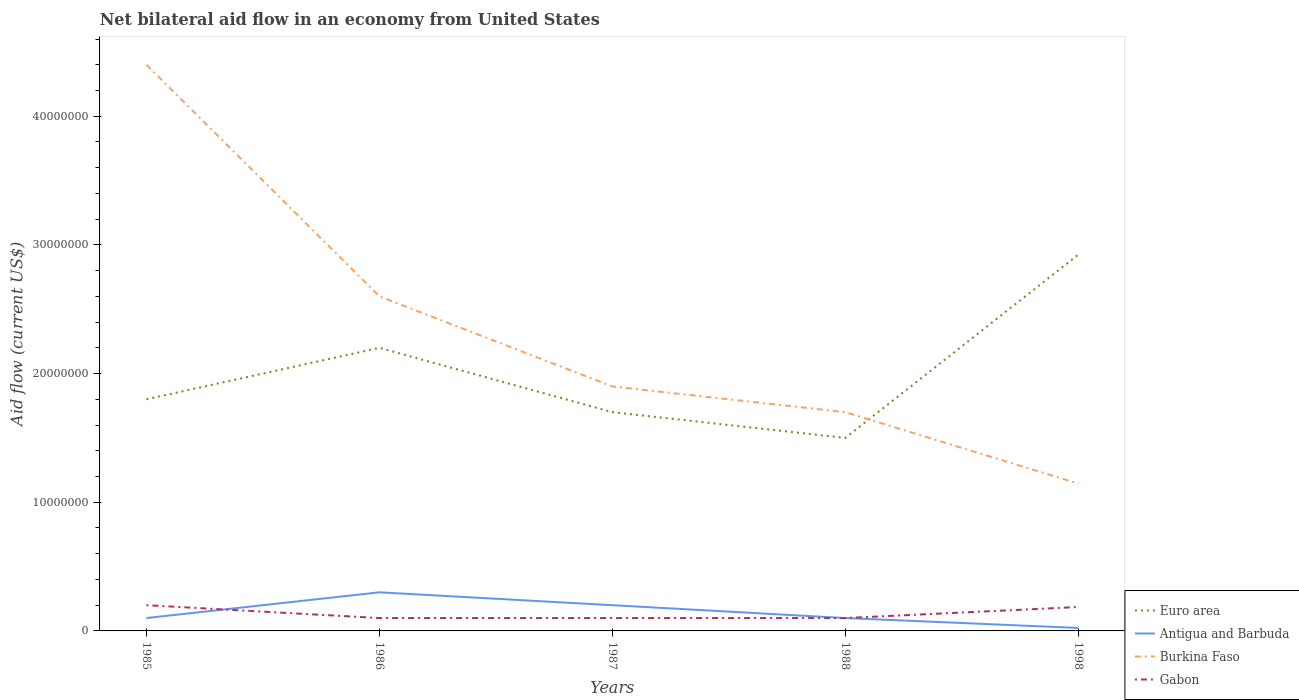Is the number of lines equal to the number of legend labels?
Your answer should be compact. Yes. Across all years, what is the maximum net bilateral aid flow in Euro area?
Offer a very short reply. 1.50e+07. What is the total net bilateral aid flow in Euro area in the graph?
Your answer should be very brief. 7.00e+06. What is the difference between the highest and the second highest net bilateral aid flow in Burkina Faso?
Keep it short and to the point. 3.26e+07. How many lines are there?
Your answer should be compact. 4. How many years are there in the graph?
Your answer should be compact. 5. What is the difference between two consecutive major ticks on the Y-axis?
Your answer should be very brief. 1.00e+07. Are the values on the major ticks of Y-axis written in scientific E-notation?
Your response must be concise. No. Does the graph contain any zero values?
Your response must be concise. No. How are the legend labels stacked?
Keep it short and to the point. Vertical. What is the title of the graph?
Your response must be concise. Net bilateral aid flow in an economy from United States. What is the label or title of the X-axis?
Your answer should be compact. Years. What is the Aid flow (current US$) in Euro area in 1985?
Offer a very short reply. 1.80e+07. What is the Aid flow (current US$) in Burkina Faso in 1985?
Your answer should be very brief. 4.40e+07. What is the Aid flow (current US$) in Gabon in 1985?
Offer a terse response. 2.00e+06. What is the Aid flow (current US$) of Euro area in 1986?
Your answer should be very brief. 2.20e+07. What is the Aid flow (current US$) of Burkina Faso in 1986?
Give a very brief answer. 2.60e+07. What is the Aid flow (current US$) in Gabon in 1986?
Your answer should be compact. 1.00e+06. What is the Aid flow (current US$) in Euro area in 1987?
Keep it short and to the point. 1.70e+07. What is the Aid flow (current US$) of Antigua and Barbuda in 1987?
Offer a very short reply. 2.00e+06. What is the Aid flow (current US$) in Burkina Faso in 1987?
Provide a succinct answer. 1.90e+07. What is the Aid flow (current US$) in Gabon in 1987?
Provide a succinct answer. 1.00e+06. What is the Aid flow (current US$) in Euro area in 1988?
Your answer should be very brief. 1.50e+07. What is the Aid flow (current US$) of Burkina Faso in 1988?
Offer a very short reply. 1.70e+07. What is the Aid flow (current US$) of Euro area in 1998?
Ensure brevity in your answer.  2.92e+07. What is the Aid flow (current US$) of Antigua and Barbuda in 1998?
Make the answer very short. 2.30e+05. What is the Aid flow (current US$) of Burkina Faso in 1998?
Provide a succinct answer. 1.14e+07. What is the Aid flow (current US$) of Gabon in 1998?
Ensure brevity in your answer.  1.86e+06. Across all years, what is the maximum Aid flow (current US$) in Euro area?
Your answer should be compact. 2.92e+07. Across all years, what is the maximum Aid flow (current US$) of Burkina Faso?
Give a very brief answer. 4.40e+07. Across all years, what is the maximum Aid flow (current US$) of Gabon?
Make the answer very short. 2.00e+06. Across all years, what is the minimum Aid flow (current US$) in Euro area?
Your answer should be compact. 1.50e+07. Across all years, what is the minimum Aid flow (current US$) of Burkina Faso?
Give a very brief answer. 1.14e+07. What is the total Aid flow (current US$) in Euro area in the graph?
Offer a very short reply. 1.01e+08. What is the total Aid flow (current US$) of Antigua and Barbuda in the graph?
Offer a terse response. 7.23e+06. What is the total Aid flow (current US$) of Burkina Faso in the graph?
Ensure brevity in your answer.  1.17e+08. What is the total Aid flow (current US$) in Gabon in the graph?
Your answer should be very brief. 6.86e+06. What is the difference between the Aid flow (current US$) in Euro area in 1985 and that in 1986?
Give a very brief answer. -4.00e+06. What is the difference between the Aid flow (current US$) of Antigua and Barbuda in 1985 and that in 1986?
Your response must be concise. -2.00e+06. What is the difference between the Aid flow (current US$) of Burkina Faso in 1985 and that in 1986?
Give a very brief answer. 1.80e+07. What is the difference between the Aid flow (current US$) of Antigua and Barbuda in 1985 and that in 1987?
Provide a short and direct response. -1.00e+06. What is the difference between the Aid flow (current US$) in Burkina Faso in 1985 and that in 1987?
Provide a short and direct response. 2.50e+07. What is the difference between the Aid flow (current US$) of Euro area in 1985 and that in 1988?
Your response must be concise. 3.00e+06. What is the difference between the Aid flow (current US$) in Burkina Faso in 1985 and that in 1988?
Keep it short and to the point. 2.70e+07. What is the difference between the Aid flow (current US$) of Euro area in 1985 and that in 1998?
Your answer should be very brief. -1.12e+07. What is the difference between the Aid flow (current US$) in Antigua and Barbuda in 1985 and that in 1998?
Give a very brief answer. 7.70e+05. What is the difference between the Aid flow (current US$) in Burkina Faso in 1985 and that in 1998?
Offer a terse response. 3.26e+07. What is the difference between the Aid flow (current US$) in Gabon in 1986 and that in 1987?
Ensure brevity in your answer.  0. What is the difference between the Aid flow (current US$) of Burkina Faso in 1986 and that in 1988?
Offer a terse response. 9.00e+06. What is the difference between the Aid flow (current US$) in Gabon in 1986 and that in 1988?
Keep it short and to the point. 0. What is the difference between the Aid flow (current US$) of Euro area in 1986 and that in 1998?
Give a very brief answer. -7.24e+06. What is the difference between the Aid flow (current US$) of Antigua and Barbuda in 1986 and that in 1998?
Provide a short and direct response. 2.77e+06. What is the difference between the Aid flow (current US$) in Burkina Faso in 1986 and that in 1998?
Keep it short and to the point. 1.46e+07. What is the difference between the Aid flow (current US$) in Gabon in 1986 and that in 1998?
Your answer should be very brief. -8.60e+05. What is the difference between the Aid flow (current US$) of Antigua and Barbuda in 1987 and that in 1988?
Make the answer very short. 1.00e+06. What is the difference between the Aid flow (current US$) of Gabon in 1987 and that in 1988?
Offer a terse response. 0. What is the difference between the Aid flow (current US$) in Euro area in 1987 and that in 1998?
Your answer should be very brief. -1.22e+07. What is the difference between the Aid flow (current US$) in Antigua and Barbuda in 1987 and that in 1998?
Provide a short and direct response. 1.77e+06. What is the difference between the Aid flow (current US$) in Burkina Faso in 1987 and that in 1998?
Provide a succinct answer. 7.55e+06. What is the difference between the Aid flow (current US$) in Gabon in 1987 and that in 1998?
Offer a very short reply. -8.60e+05. What is the difference between the Aid flow (current US$) of Euro area in 1988 and that in 1998?
Provide a short and direct response. -1.42e+07. What is the difference between the Aid flow (current US$) of Antigua and Barbuda in 1988 and that in 1998?
Your answer should be very brief. 7.70e+05. What is the difference between the Aid flow (current US$) in Burkina Faso in 1988 and that in 1998?
Your answer should be very brief. 5.55e+06. What is the difference between the Aid flow (current US$) in Gabon in 1988 and that in 1998?
Your response must be concise. -8.60e+05. What is the difference between the Aid flow (current US$) of Euro area in 1985 and the Aid flow (current US$) of Antigua and Barbuda in 1986?
Provide a short and direct response. 1.50e+07. What is the difference between the Aid flow (current US$) in Euro area in 1985 and the Aid flow (current US$) in Burkina Faso in 1986?
Your response must be concise. -8.00e+06. What is the difference between the Aid flow (current US$) in Euro area in 1985 and the Aid flow (current US$) in Gabon in 1986?
Ensure brevity in your answer.  1.70e+07. What is the difference between the Aid flow (current US$) of Antigua and Barbuda in 1985 and the Aid flow (current US$) of Burkina Faso in 1986?
Offer a very short reply. -2.50e+07. What is the difference between the Aid flow (current US$) in Burkina Faso in 1985 and the Aid flow (current US$) in Gabon in 1986?
Your answer should be compact. 4.30e+07. What is the difference between the Aid flow (current US$) of Euro area in 1985 and the Aid flow (current US$) of Antigua and Barbuda in 1987?
Make the answer very short. 1.60e+07. What is the difference between the Aid flow (current US$) of Euro area in 1985 and the Aid flow (current US$) of Burkina Faso in 1987?
Provide a short and direct response. -1.00e+06. What is the difference between the Aid flow (current US$) in Euro area in 1985 and the Aid flow (current US$) in Gabon in 1987?
Keep it short and to the point. 1.70e+07. What is the difference between the Aid flow (current US$) in Antigua and Barbuda in 1985 and the Aid flow (current US$) in Burkina Faso in 1987?
Keep it short and to the point. -1.80e+07. What is the difference between the Aid flow (current US$) in Antigua and Barbuda in 1985 and the Aid flow (current US$) in Gabon in 1987?
Keep it short and to the point. 0. What is the difference between the Aid flow (current US$) in Burkina Faso in 1985 and the Aid flow (current US$) in Gabon in 1987?
Your response must be concise. 4.30e+07. What is the difference between the Aid flow (current US$) in Euro area in 1985 and the Aid flow (current US$) in Antigua and Barbuda in 1988?
Ensure brevity in your answer.  1.70e+07. What is the difference between the Aid flow (current US$) of Euro area in 1985 and the Aid flow (current US$) of Gabon in 1988?
Keep it short and to the point. 1.70e+07. What is the difference between the Aid flow (current US$) of Antigua and Barbuda in 1985 and the Aid flow (current US$) of Burkina Faso in 1988?
Provide a succinct answer. -1.60e+07. What is the difference between the Aid flow (current US$) of Antigua and Barbuda in 1985 and the Aid flow (current US$) of Gabon in 1988?
Your response must be concise. 0. What is the difference between the Aid flow (current US$) of Burkina Faso in 1985 and the Aid flow (current US$) of Gabon in 1988?
Make the answer very short. 4.30e+07. What is the difference between the Aid flow (current US$) in Euro area in 1985 and the Aid flow (current US$) in Antigua and Barbuda in 1998?
Make the answer very short. 1.78e+07. What is the difference between the Aid flow (current US$) of Euro area in 1985 and the Aid flow (current US$) of Burkina Faso in 1998?
Your answer should be compact. 6.55e+06. What is the difference between the Aid flow (current US$) of Euro area in 1985 and the Aid flow (current US$) of Gabon in 1998?
Provide a short and direct response. 1.61e+07. What is the difference between the Aid flow (current US$) of Antigua and Barbuda in 1985 and the Aid flow (current US$) of Burkina Faso in 1998?
Offer a terse response. -1.04e+07. What is the difference between the Aid flow (current US$) of Antigua and Barbuda in 1985 and the Aid flow (current US$) of Gabon in 1998?
Your response must be concise. -8.60e+05. What is the difference between the Aid flow (current US$) of Burkina Faso in 1985 and the Aid flow (current US$) of Gabon in 1998?
Offer a terse response. 4.21e+07. What is the difference between the Aid flow (current US$) in Euro area in 1986 and the Aid flow (current US$) in Gabon in 1987?
Provide a succinct answer. 2.10e+07. What is the difference between the Aid flow (current US$) in Antigua and Barbuda in 1986 and the Aid flow (current US$) in Burkina Faso in 1987?
Make the answer very short. -1.60e+07. What is the difference between the Aid flow (current US$) in Burkina Faso in 1986 and the Aid flow (current US$) in Gabon in 1987?
Make the answer very short. 2.50e+07. What is the difference between the Aid flow (current US$) of Euro area in 1986 and the Aid flow (current US$) of Antigua and Barbuda in 1988?
Ensure brevity in your answer.  2.10e+07. What is the difference between the Aid flow (current US$) in Euro area in 1986 and the Aid flow (current US$) in Burkina Faso in 1988?
Keep it short and to the point. 5.00e+06. What is the difference between the Aid flow (current US$) in Euro area in 1986 and the Aid flow (current US$) in Gabon in 1988?
Make the answer very short. 2.10e+07. What is the difference between the Aid flow (current US$) in Antigua and Barbuda in 1986 and the Aid flow (current US$) in Burkina Faso in 1988?
Offer a terse response. -1.40e+07. What is the difference between the Aid flow (current US$) in Antigua and Barbuda in 1986 and the Aid flow (current US$) in Gabon in 1988?
Provide a succinct answer. 2.00e+06. What is the difference between the Aid flow (current US$) of Burkina Faso in 1986 and the Aid flow (current US$) of Gabon in 1988?
Your answer should be compact. 2.50e+07. What is the difference between the Aid flow (current US$) in Euro area in 1986 and the Aid flow (current US$) in Antigua and Barbuda in 1998?
Give a very brief answer. 2.18e+07. What is the difference between the Aid flow (current US$) of Euro area in 1986 and the Aid flow (current US$) of Burkina Faso in 1998?
Provide a short and direct response. 1.06e+07. What is the difference between the Aid flow (current US$) in Euro area in 1986 and the Aid flow (current US$) in Gabon in 1998?
Offer a very short reply. 2.01e+07. What is the difference between the Aid flow (current US$) in Antigua and Barbuda in 1986 and the Aid flow (current US$) in Burkina Faso in 1998?
Offer a very short reply. -8.45e+06. What is the difference between the Aid flow (current US$) in Antigua and Barbuda in 1986 and the Aid flow (current US$) in Gabon in 1998?
Your answer should be compact. 1.14e+06. What is the difference between the Aid flow (current US$) of Burkina Faso in 1986 and the Aid flow (current US$) of Gabon in 1998?
Keep it short and to the point. 2.41e+07. What is the difference between the Aid flow (current US$) in Euro area in 1987 and the Aid flow (current US$) in Antigua and Barbuda in 1988?
Ensure brevity in your answer.  1.60e+07. What is the difference between the Aid flow (current US$) of Euro area in 1987 and the Aid flow (current US$) of Burkina Faso in 1988?
Provide a short and direct response. 0. What is the difference between the Aid flow (current US$) in Euro area in 1987 and the Aid flow (current US$) in Gabon in 1988?
Offer a very short reply. 1.60e+07. What is the difference between the Aid flow (current US$) in Antigua and Barbuda in 1987 and the Aid flow (current US$) in Burkina Faso in 1988?
Provide a succinct answer. -1.50e+07. What is the difference between the Aid flow (current US$) in Antigua and Barbuda in 1987 and the Aid flow (current US$) in Gabon in 1988?
Your response must be concise. 1.00e+06. What is the difference between the Aid flow (current US$) in Burkina Faso in 1987 and the Aid flow (current US$) in Gabon in 1988?
Your answer should be compact. 1.80e+07. What is the difference between the Aid flow (current US$) in Euro area in 1987 and the Aid flow (current US$) in Antigua and Barbuda in 1998?
Keep it short and to the point. 1.68e+07. What is the difference between the Aid flow (current US$) in Euro area in 1987 and the Aid flow (current US$) in Burkina Faso in 1998?
Provide a succinct answer. 5.55e+06. What is the difference between the Aid flow (current US$) of Euro area in 1987 and the Aid flow (current US$) of Gabon in 1998?
Offer a terse response. 1.51e+07. What is the difference between the Aid flow (current US$) in Antigua and Barbuda in 1987 and the Aid flow (current US$) in Burkina Faso in 1998?
Keep it short and to the point. -9.45e+06. What is the difference between the Aid flow (current US$) of Burkina Faso in 1987 and the Aid flow (current US$) of Gabon in 1998?
Make the answer very short. 1.71e+07. What is the difference between the Aid flow (current US$) in Euro area in 1988 and the Aid flow (current US$) in Antigua and Barbuda in 1998?
Your response must be concise. 1.48e+07. What is the difference between the Aid flow (current US$) of Euro area in 1988 and the Aid flow (current US$) of Burkina Faso in 1998?
Provide a succinct answer. 3.55e+06. What is the difference between the Aid flow (current US$) in Euro area in 1988 and the Aid flow (current US$) in Gabon in 1998?
Provide a short and direct response. 1.31e+07. What is the difference between the Aid flow (current US$) in Antigua and Barbuda in 1988 and the Aid flow (current US$) in Burkina Faso in 1998?
Your answer should be very brief. -1.04e+07. What is the difference between the Aid flow (current US$) in Antigua and Barbuda in 1988 and the Aid flow (current US$) in Gabon in 1998?
Make the answer very short. -8.60e+05. What is the difference between the Aid flow (current US$) of Burkina Faso in 1988 and the Aid flow (current US$) of Gabon in 1998?
Give a very brief answer. 1.51e+07. What is the average Aid flow (current US$) of Euro area per year?
Give a very brief answer. 2.02e+07. What is the average Aid flow (current US$) in Antigua and Barbuda per year?
Offer a terse response. 1.45e+06. What is the average Aid flow (current US$) in Burkina Faso per year?
Provide a short and direct response. 2.35e+07. What is the average Aid flow (current US$) in Gabon per year?
Ensure brevity in your answer.  1.37e+06. In the year 1985, what is the difference between the Aid flow (current US$) in Euro area and Aid flow (current US$) in Antigua and Barbuda?
Provide a short and direct response. 1.70e+07. In the year 1985, what is the difference between the Aid flow (current US$) of Euro area and Aid flow (current US$) of Burkina Faso?
Give a very brief answer. -2.60e+07. In the year 1985, what is the difference between the Aid flow (current US$) in Euro area and Aid flow (current US$) in Gabon?
Your answer should be compact. 1.60e+07. In the year 1985, what is the difference between the Aid flow (current US$) in Antigua and Barbuda and Aid flow (current US$) in Burkina Faso?
Provide a short and direct response. -4.30e+07. In the year 1985, what is the difference between the Aid flow (current US$) of Antigua and Barbuda and Aid flow (current US$) of Gabon?
Make the answer very short. -1.00e+06. In the year 1985, what is the difference between the Aid flow (current US$) of Burkina Faso and Aid flow (current US$) of Gabon?
Give a very brief answer. 4.20e+07. In the year 1986, what is the difference between the Aid flow (current US$) in Euro area and Aid flow (current US$) in Antigua and Barbuda?
Keep it short and to the point. 1.90e+07. In the year 1986, what is the difference between the Aid flow (current US$) in Euro area and Aid flow (current US$) in Burkina Faso?
Your answer should be very brief. -4.00e+06. In the year 1986, what is the difference between the Aid flow (current US$) in Euro area and Aid flow (current US$) in Gabon?
Your answer should be very brief. 2.10e+07. In the year 1986, what is the difference between the Aid flow (current US$) in Antigua and Barbuda and Aid flow (current US$) in Burkina Faso?
Make the answer very short. -2.30e+07. In the year 1986, what is the difference between the Aid flow (current US$) of Antigua and Barbuda and Aid flow (current US$) of Gabon?
Keep it short and to the point. 2.00e+06. In the year 1986, what is the difference between the Aid flow (current US$) of Burkina Faso and Aid flow (current US$) of Gabon?
Offer a very short reply. 2.50e+07. In the year 1987, what is the difference between the Aid flow (current US$) of Euro area and Aid flow (current US$) of Antigua and Barbuda?
Make the answer very short. 1.50e+07. In the year 1987, what is the difference between the Aid flow (current US$) of Euro area and Aid flow (current US$) of Burkina Faso?
Provide a succinct answer. -2.00e+06. In the year 1987, what is the difference between the Aid flow (current US$) of Euro area and Aid flow (current US$) of Gabon?
Your answer should be compact. 1.60e+07. In the year 1987, what is the difference between the Aid flow (current US$) in Antigua and Barbuda and Aid flow (current US$) in Burkina Faso?
Provide a short and direct response. -1.70e+07. In the year 1987, what is the difference between the Aid flow (current US$) of Antigua and Barbuda and Aid flow (current US$) of Gabon?
Provide a short and direct response. 1.00e+06. In the year 1987, what is the difference between the Aid flow (current US$) in Burkina Faso and Aid flow (current US$) in Gabon?
Your answer should be very brief. 1.80e+07. In the year 1988, what is the difference between the Aid flow (current US$) in Euro area and Aid flow (current US$) in Antigua and Barbuda?
Provide a succinct answer. 1.40e+07. In the year 1988, what is the difference between the Aid flow (current US$) of Euro area and Aid flow (current US$) of Gabon?
Provide a succinct answer. 1.40e+07. In the year 1988, what is the difference between the Aid flow (current US$) of Antigua and Barbuda and Aid flow (current US$) of Burkina Faso?
Provide a short and direct response. -1.60e+07. In the year 1988, what is the difference between the Aid flow (current US$) in Antigua and Barbuda and Aid flow (current US$) in Gabon?
Make the answer very short. 0. In the year 1988, what is the difference between the Aid flow (current US$) of Burkina Faso and Aid flow (current US$) of Gabon?
Your response must be concise. 1.60e+07. In the year 1998, what is the difference between the Aid flow (current US$) in Euro area and Aid flow (current US$) in Antigua and Barbuda?
Your answer should be very brief. 2.90e+07. In the year 1998, what is the difference between the Aid flow (current US$) of Euro area and Aid flow (current US$) of Burkina Faso?
Offer a very short reply. 1.78e+07. In the year 1998, what is the difference between the Aid flow (current US$) of Euro area and Aid flow (current US$) of Gabon?
Provide a short and direct response. 2.74e+07. In the year 1998, what is the difference between the Aid flow (current US$) in Antigua and Barbuda and Aid flow (current US$) in Burkina Faso?
Make the answer very short. -1.12e+07. In the year 1998, what is the difference between the Aid flow (current US$) of Antigua and Barbuda and Aid flow (current US$) of Gabon?
Provide a short and direct response. -1.63e+06. In the year 1998, what is the difference between the Aid flow (current US$) of Burkina Faso and Aid flow (current US$) of Gabon?
Your answer should be compact. 9.59e+06. What is the ratio of the Aid flow (current US$) in Euro area in 1985 to that in 1986?
Provide a succinct answer. 0.82. What is the ratio of the Aid flow (current US$) of Antigua and Barbuda in 1985 to that in 1986?
Offer a terse response. 0.33. What is the ratio of the Aid flow (current US$) of Burkina Faso in 1985 to that in 1986?
Your answer should be compact. 1.69. What is the ratio of the Aid flow (current US$) of Euro area in 1985 to that in 1987?
Give a very brief answer. 1.06. What is the ratio of the Aid flow (current US$) in Antigua and Barbuda in 1985 to that in 1987?
Your answer should be very brief. 0.5. What is the ratio of the Aid flow (current US$) in Burkina Faso in 1985 to that in 1987?
Your answer should be very brief. 2.32. What is the ratio of the Aid flow (current US$) in Gabon in 1985 to that in 1987?
Provide a succinct answer. 2. What is the ratio of the Aid flow (current US$) of Euro area in 1985 to that in 1988?
Your answer should be compact. 1.2. What is the ratio of the Aid flow (current US$) in Burkina Faso in 1985 to that in 1988?
Your answer should be compact. 2.59. What is the ratio of the Aid flow (current US$) of Gabon in 1985 to that in 1988?
Provide a short and direct response. 2. What is the ratio of the Aid flow (current US$) of Euro area in 1985 to that in 1998?
Provide a succinct answer. 0.62. What is the ratio of the Aid flow (current US$) of Antigua and Barbuda in 1985 to that in 1998?
Provide a succinct answer. 4.35. What is the ratio of the Aid flow (current US$) in Burkina Faso in 1985 to that in 1998?
Ensure brevity in your answer.  3.84. What is the ratio of the Aid flow (current US$) of Gabon in 1985 to that in 1998?
Your response must be concise. 1.08. What is the ratio of the Aid flow (current US$) in Euro area in 1986 to that in 1987?
Offer a terse response. 1.29. What is the ratio of the Aid flow (current US$) of Burkina Faso in 1986 to that in 1987?
Provide a succinct answer. 1.37. What is the ratio of the Aid flow (current US$) of Gabon in 1986 to that in 1987?
Offer a very short reply. 1. What is the ratio of the Aid flow (current US$) in Euro area in 1986 to that in 1988?
Ensure brevity in your answer.  1.47. What is the ratio of the Aid flow (current US$) of Burkina Faso in 1986 to that in 1988?
Ensure brevity in your answer.  1.53. What is the ratio of the Aid flow (current US$) in Gabon in 1986 to that in 1988?
Offer a very short reply. 1. What is the ratio of the Aid flow (current US$) of Euro area in 1986 to that in 1998?
Make the answer very short. 0.75. What is the ratio of the Aid flow (current US$) of Antigua and Barbuda in 1986 to that in 1998?
Make the answer very short. 13.04. What is the ratio of the Aid flow (current US$) in Burkina Faso in 1986 to that in 1998?
Provide a succinct answer. 2.27. What is the ratio of the Aid flow (current US$) of Gabon in 1986 to that in 1998?
Offer a terse response. 0.54. What is the ratio of the Aid flow (current US$) of Euro area in 1987 to that in 1988?
Provide a short and direct response. 1.13. What is the ratio of the Aid flow (current US$) of Antigua and Barbuda in 1987 to that in 1988?
Offer a terse response. 2. What is the ratio of the Aid flow (current US$) of Burkina Faso in 1987 to that in 1988?
Provide a succinct answer. 1.12. What is the ratio of the Aid flow (current US$) in Euro area in 1987 to that in 1998?
Make the answer very short. 0.58. What is the ratio of the Aid flow (current US$) of Antigua and Barbuda in 1987 to that in 1998?
Provide a succinct answer. 8.7. What is the ratio of the Aid flow (current US$) of Burkina Faso in 1987 to that in 1998?
Make the answer very short. 1.66. What is the ratio of the Aid flow (current US$) in Gabon in 1987 to that in 1998?
Provide a short and direct response. 0.54. What is the ratio of the Aid flow (current US$) of Euro area in 1988 to that in 1998?
Your response must be concise. 0.51. What is the ratio of the Aid flow (current US$) in Antigua and Barbuda in 1988 to that in 1998?
Provide a succinct answer. 4.35. What is the ratio of the Aid flow (current US$) of Burkina Faso in 1988 to that in 1998?
Your answer should be compact. 1.48. What is the ratio of the Aid flow (current US$) in Gabon in 1988 to that in 1998?
Provide a short and direct response. 0.54. What is the difference between the highest and the second highest Aid flow (current US$) in Euro area?
Your response must be concise. 7.24e+06. What is the difference between the highest and the second highest Aid flow (current US$) in Antigua and Barbuda?
Your response must be concise. 1.00e+06. What is the difference between the highest and the second highest Aid flow (current US$) in Burkina Faso?
Keep it short and to the point. 1.80e+07. What is the difference between the highest and the second highest Aid flow (current US$) in Gabon?
Your answer should be very brief. 1.40e+05. What is the difference between the highest and the lowest Aid flow (current US$) in Euro area?
Provide a short and direct response. 1.42e+07. What is the difference between the highest and the lowest Aid flow (current US$) of Antigua and Barbuda?
Give a very brief answer. 2.77e+06. What is the difference between the highest and the lowest Aid flow (current US$) of Burkina Faso?
Your response must be concise. 3.26e+07. 